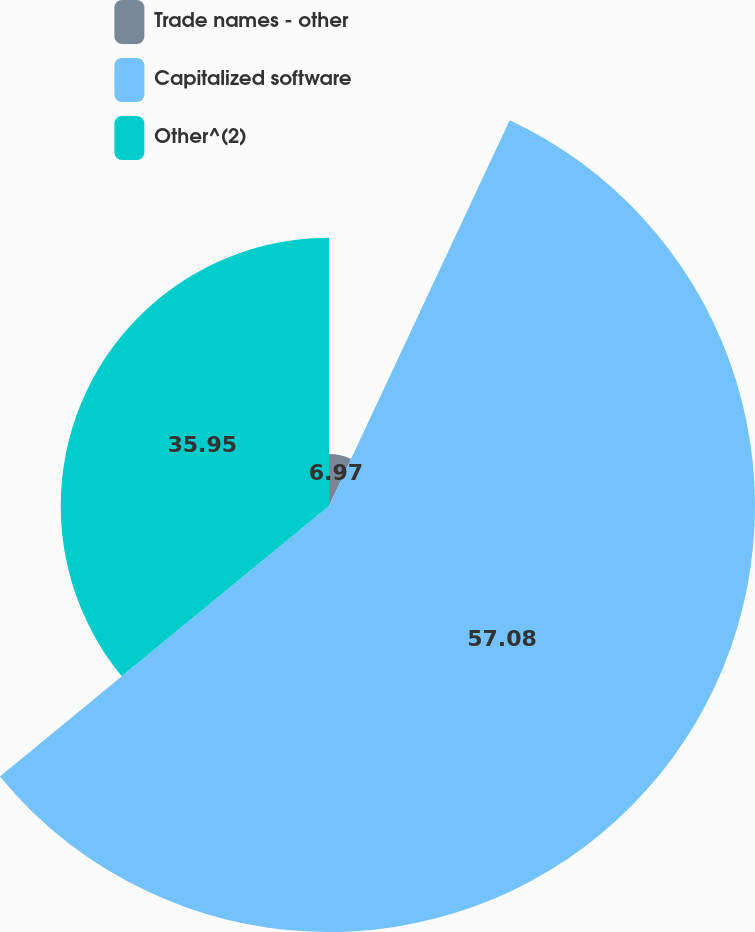Convert chart. <chart><loc_0><loc_0><loc_500><loc_500><pie_chart><fcel>Trade names - other<fcel>Capitalized software<fcel>Other^(2)<nl><fcel>6.97%<fcel>57.08%<fcel>35.95%<nl></chart> 